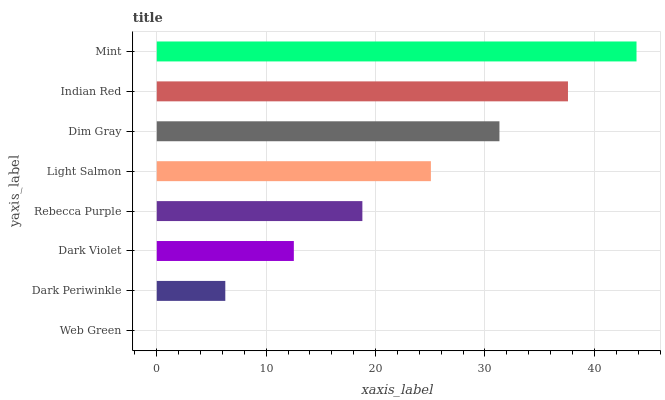Is Web Green the minimum?
Answer yes or no. Yes. Is Mint the maximum?
Answer yes or no. Yes. Is Dark Periwinkle the minimum?
Answer yes or no. No. Is Dark Periwinkle the maximum?
Answer yes or no. No. Is Dark Periwinkle greater than Web Green?
Answer yes or no. Yes. Is Web Green less than Dark Periwinkle?
Answer yes or no. Yes. Is Web Green greater than Dark Periwinkle?
Answer yes or no. No. Is Dark Periwinkle less than Web Green?
Answer yes or no. No. Is Light Salmon the high median?
Answer yes or no. Yes. Is Rebecca Purple the low median?
Answer yes or no. Yes. Is Rebecca Purple the high median?
Answer yes or no. No. Is Indian Red the low median?
Answer yes or no. No. 